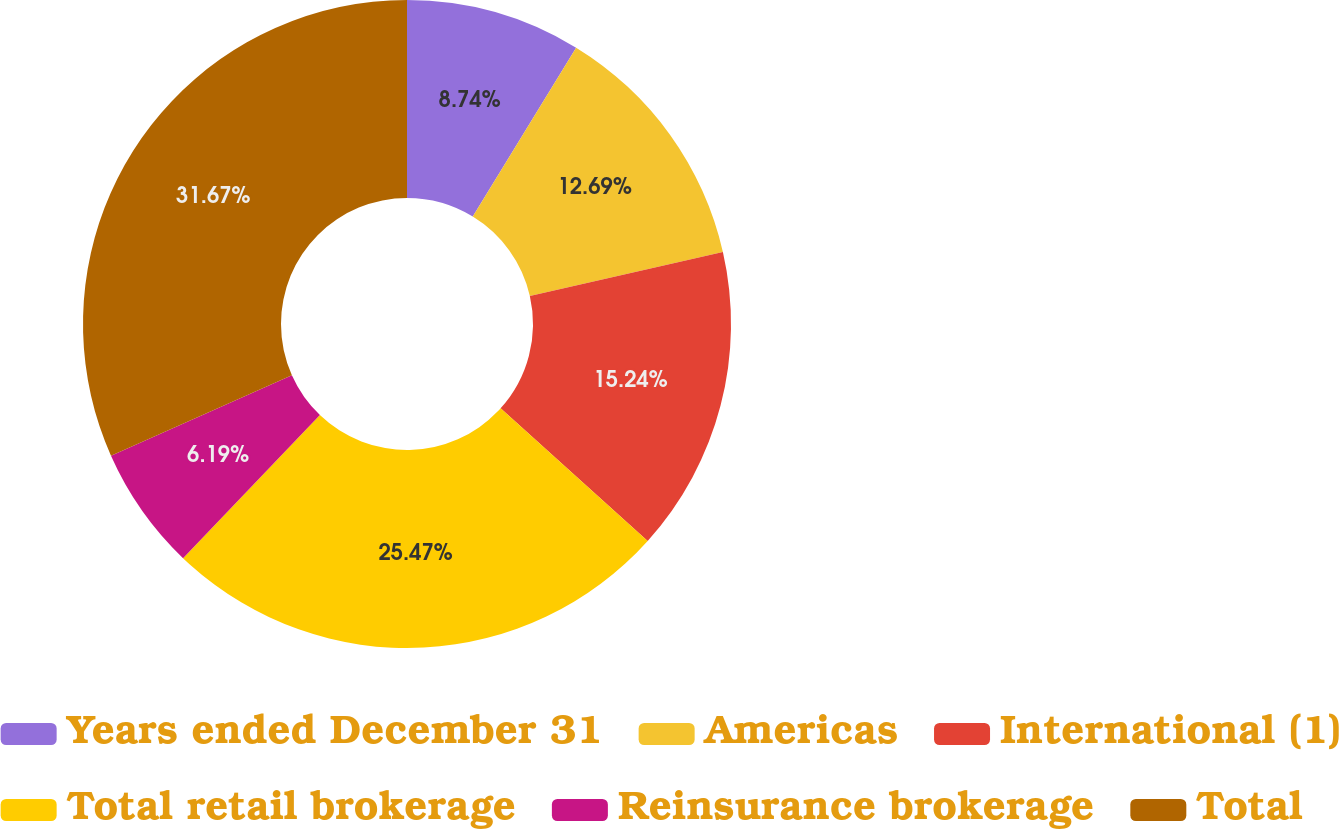<chart> <loc_0><loc_0><loc_500><loc_500><pie_chart><fcel>Years ended December 31<fcel>Americas<fcel>International (1)<fcel>Total retail brokerage<fcel>Reinsurance brokerage<fcel>Total<nl><fcel>8.74%<fcel>12.69%<fcel>15.24%<fcel>25.47%<fcel>6.19%<fcel>31.66%<nl></chart> 